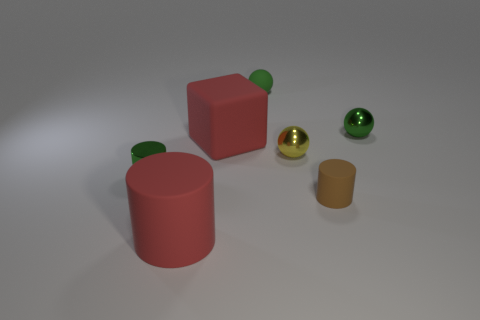Are there any balls left of the brown cylinder?
Provide a succinct answer. Yes. There is a shiny sphere in front of the big matte thing that is behind the ball in front of the big red rubber cube; what color is it?
Offer a terse response. Yellow. How many green things are behind the red block and on the left side of the rubber ball?
Your answer should be very brief. 0. What number of cylinders are red rubber things or yellow metal objects?
Your response must be concise. 1. Are there any small yellow metallic spheres?
Your response must be concise. Yes. How many other things are there of the same material as the brown cylinder?
Your response must be concise. 3. There is a brown thing that is the same size as the yellow metallic ball; what is it made of?
Offer a very short reply. Rubber. Is the shape of the small green thing in front of the small green metallic ball the same as  the tiny brown object?
Offer a very short reply. Yes. Is the color of the small metal cylinder the same as the matte ball?
Provide a succinct answer. Yes. What number of things are either small metal things that are right of the yellow thing or tiny gray objects?
Your answer should be very brief. 1. 